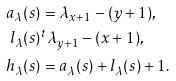Convert formula to latex. <formula><loc_0><loc_0><loc_500><loc_500>a _ { \lambda } ( s ) & = \lambda _ { x + 1 } - ( y + 1 ) , \\ l _ { \lambda } ( s ) & ^ { t } \lambda _ { y + 1 } - ( x + 1 ) , \\ h _ { \lambda } ( s ) & = a _ { \lambda } ( s ) + l _ { \lambda } ( s ) + 1 .</formula> 